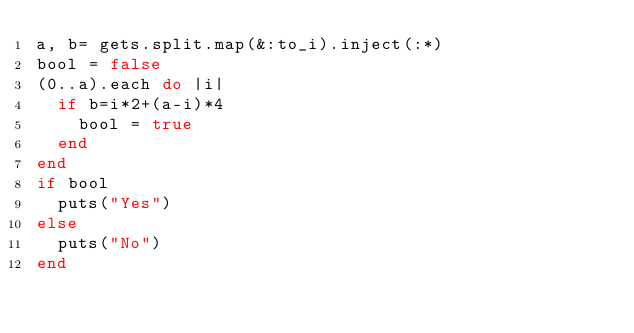Convert code to text. <code><loc_0><loc_0><loc_500><loc_500><_Ruby_>a, b= gets.split.map(&:to_i).inject(:*)
bool = false
(0..a).each do |i|
  if b=i*2+(a-i)*4
    bool = true
  end
end
if bool
  puts("Yes")
else
  puts("No")
end
</code> 